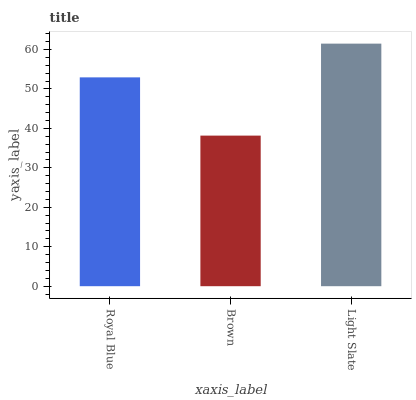Is Brown the minimum?
Answer yes or no. Yes. Is Light Slate the maximum?
Answer yes or no. Yes. Is Light Slate the minimum?
Answer yes or no. No. Is Brown the maximum?
Answer yes or no. No. Is Light Slate greater than Brown?
Answer yes or no. Yes. Is Brown less than Light Slate?
Answer yes or no. Yes. Is Brown greater than Light Slate?
Answer yes or no. No. Is Light Slate less than Brown?
Answer yes or no. No. Is Royal Blue the high median?
Answer yes or no. Yes. Is Royal Blue the low median?
Answer yes or no. Yes. Is Light Slate the high median?
Answer yes or no. No. Is Light Slate the low median?
Answer yes or no. No. 